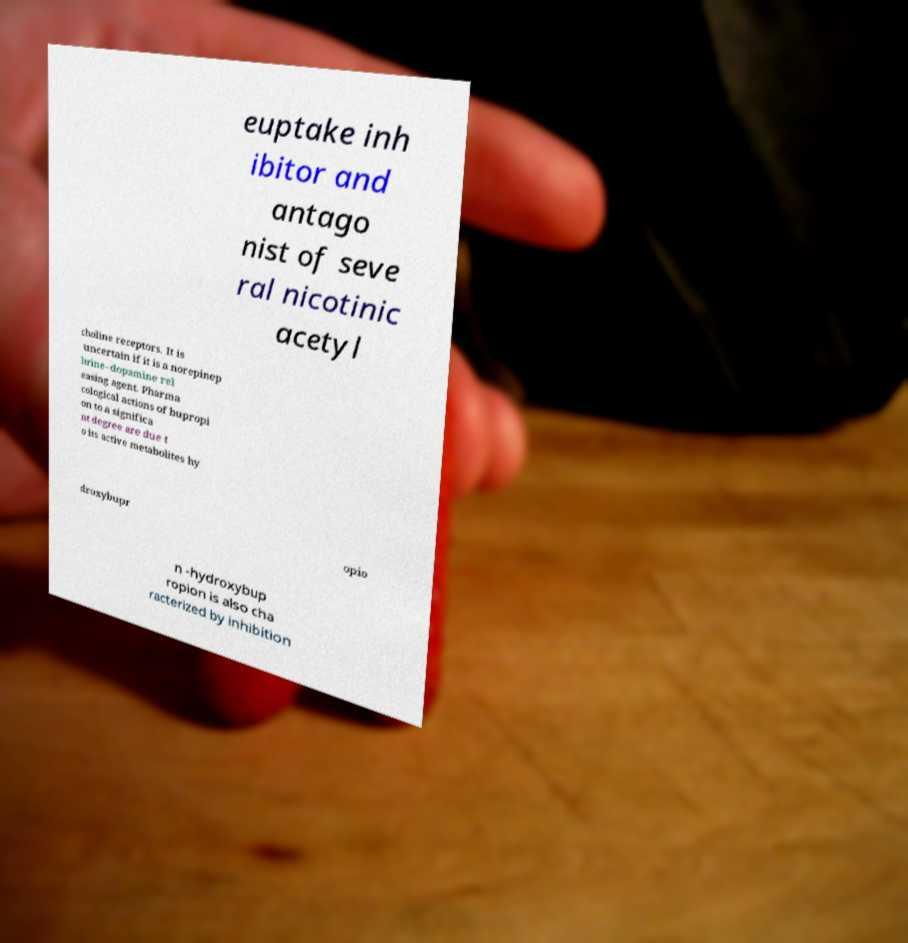There's text embedded in this image that I need extracted. Can you transcribe it verbatim? euptake inh ibitor and antago nist of seve ral nicotinic acetyl choline receptors. It is uncertain if it is a norepinep hrine–dopamine rel easing agent. Pharma cological actions of bupropi on to a significa nt degree are due t o its active metabolites hy droxybupr opio n -hydroxybup ropion is also cha racterized by inhibition 